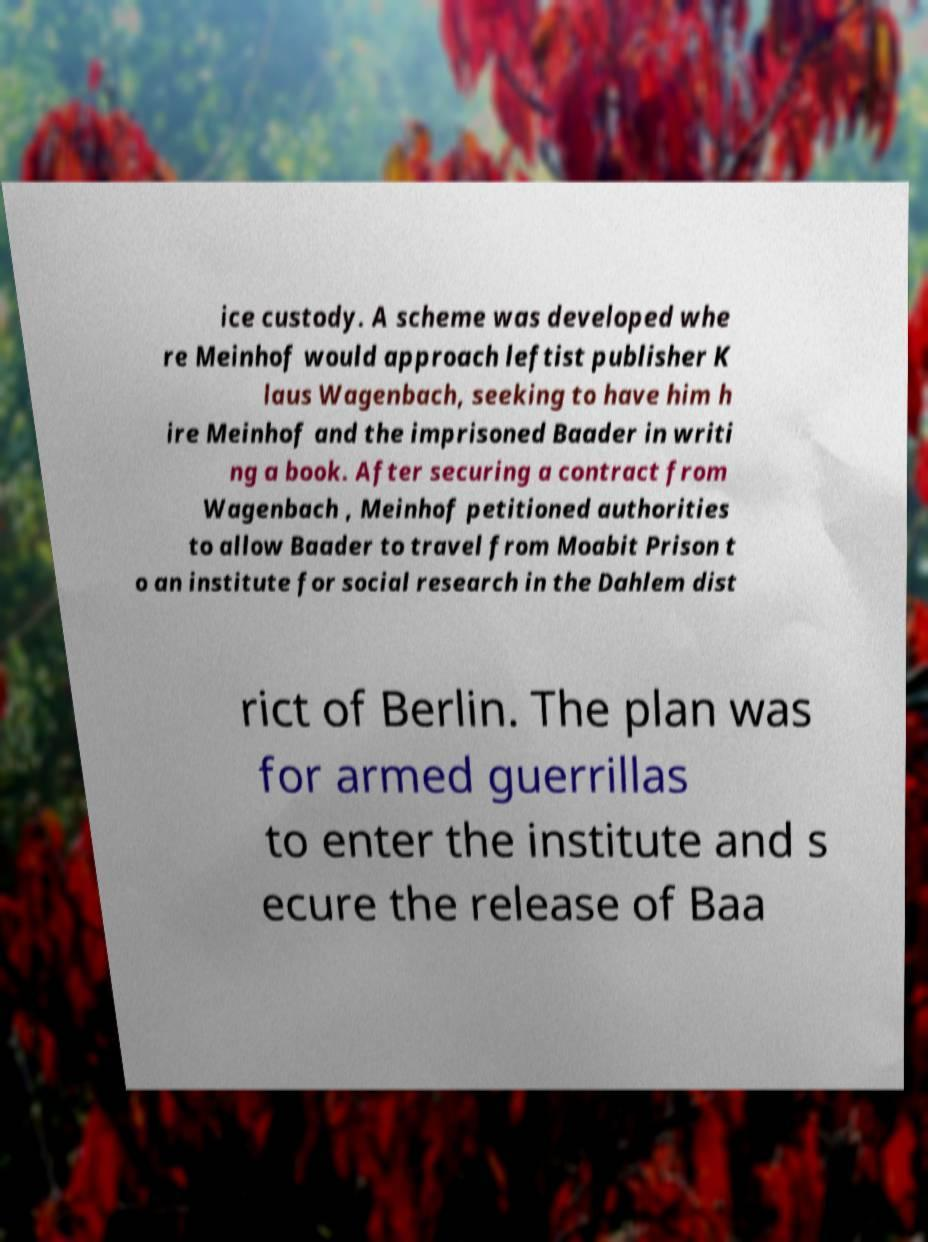Could you extract and type out the text from this image? ice custody. A scheme was developed whe re Meinhof would approach leftist publisher K laus Wagenbach, seeking to have him h ire Meinhof and the imprisoned Baader in writi ng a book. After securing a contract from Wagenbach , Meinhof petitioned authorities to allow Baader to travel from Moabit Prison t o an institute for social research in the Dahlem dist rict of Berlin. The plan was for armed guerrillas to enter the institute and s ecure the release of Baa 